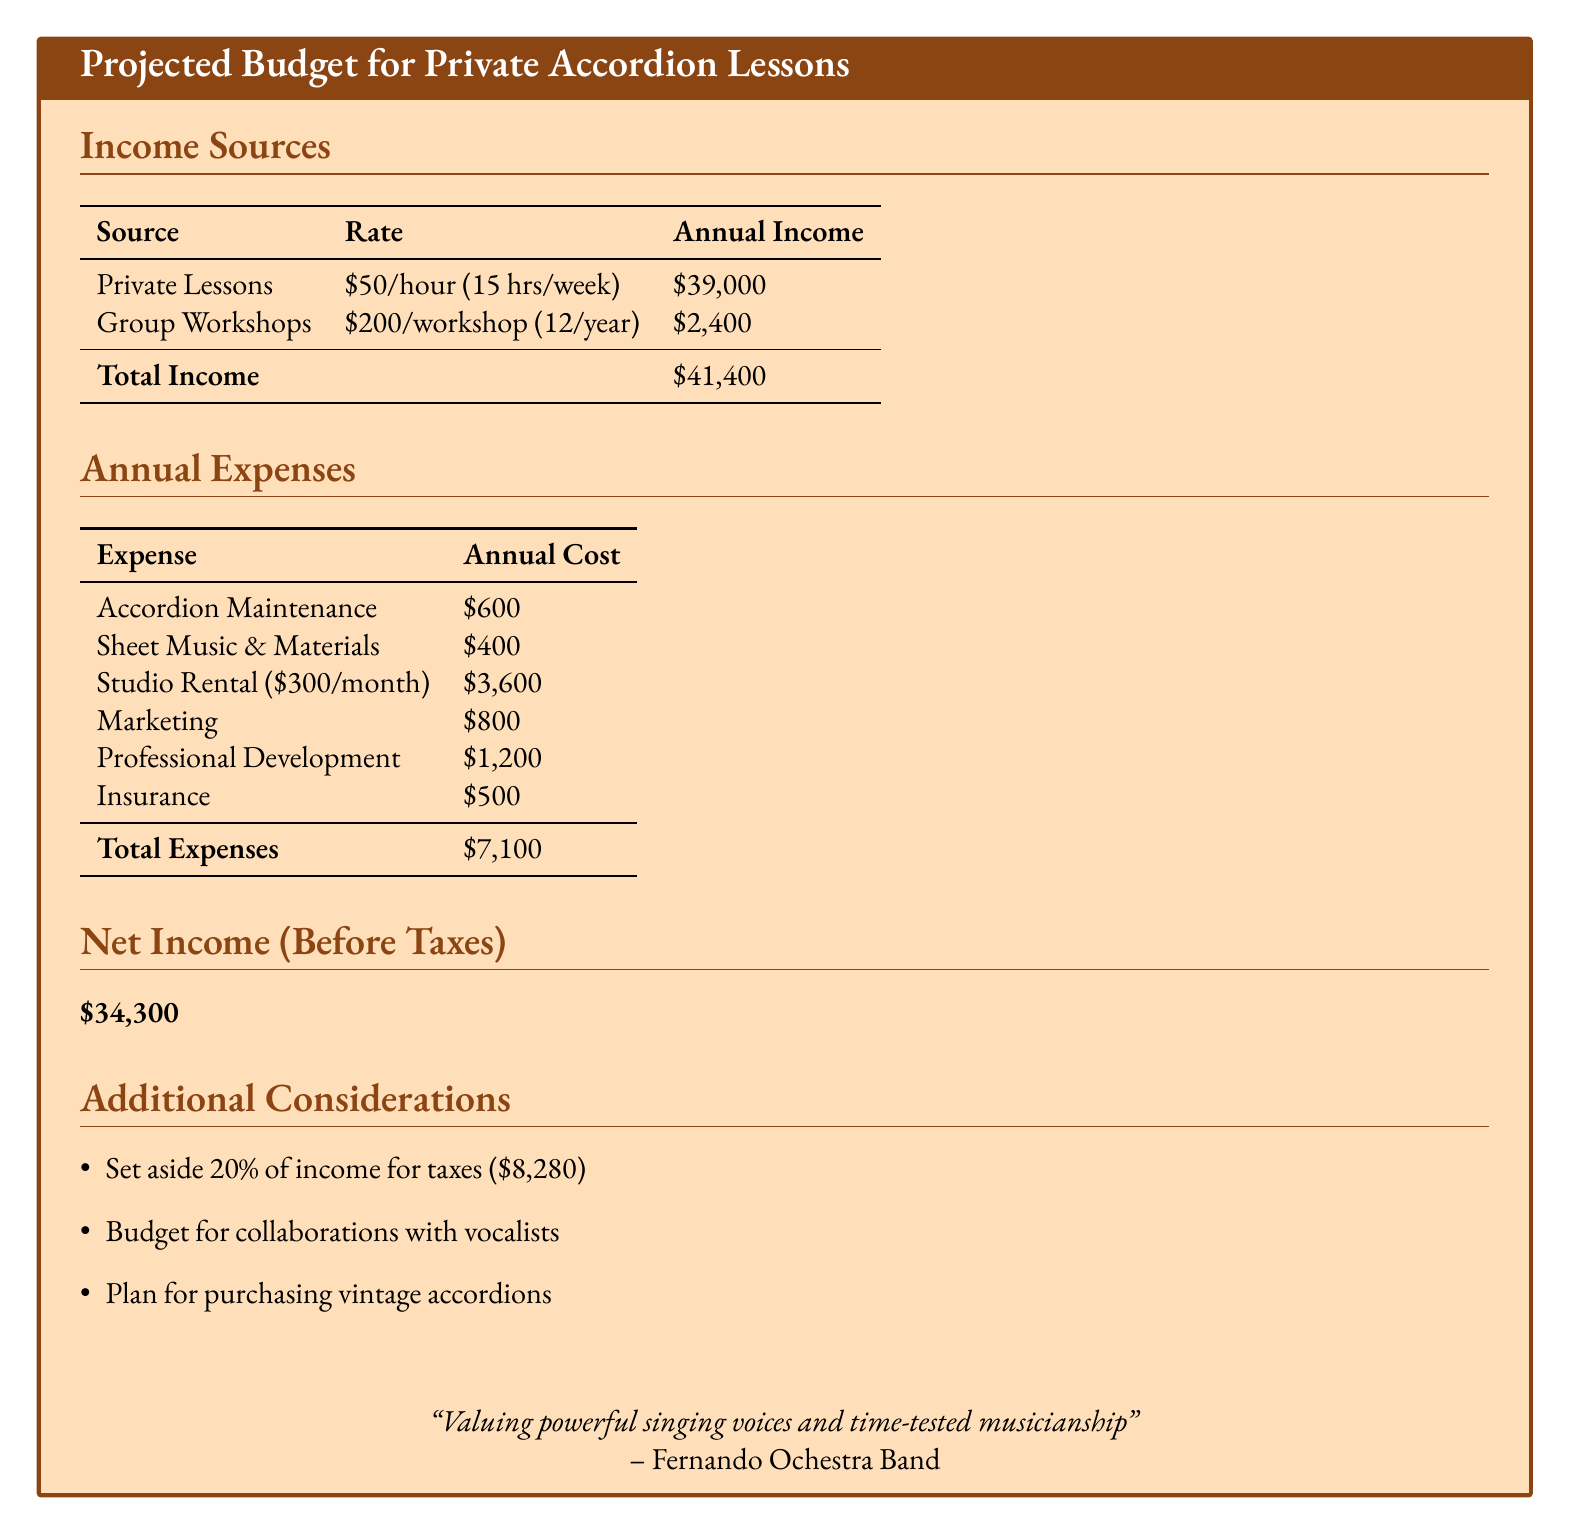What is the total income? The total income is provided in the document as the sum of private lessons and group workshops, which is $39,000 + $2,400.
Answer: $41,400 What is the cost of accordion maintenance? The document lists the expense of accordion maintenance under annual expenses as $600.
Answer: $600 How many group workshops are conducted in a year? The document indicates that there are 12 group workshops per year.
Answer: 12 What percentage of income is set aside for taxes? The document states that 20% of income is set aside for taxes.
Answer: 20% What is the total annual expense? The total annual expense is calculated as the sum of all expenses listed, which is $600 + $400 + $3,600 + $800 + $1,200 + $500.
Answer: $7,100 What is the net income before taxes? The document specifies the net income before taxes as $34,300.
Answer: $34,300 What is the annual cost of insurance? The document lists the annual cost of insurance as $500.
Answer: $500 How much is budgeted for professional development? According to the document, the budget for professional development is stated as $1,200.
Answer: $1,200 What is mentioned for collaborations in the additional considerations? The document notes that there should be a budget for collaborations with vocalists.
Answer: Collaborations with vocalists 